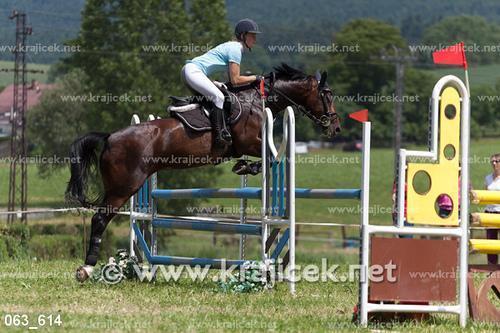How many horses are in the picture?
Give a very brief answer. 1. 